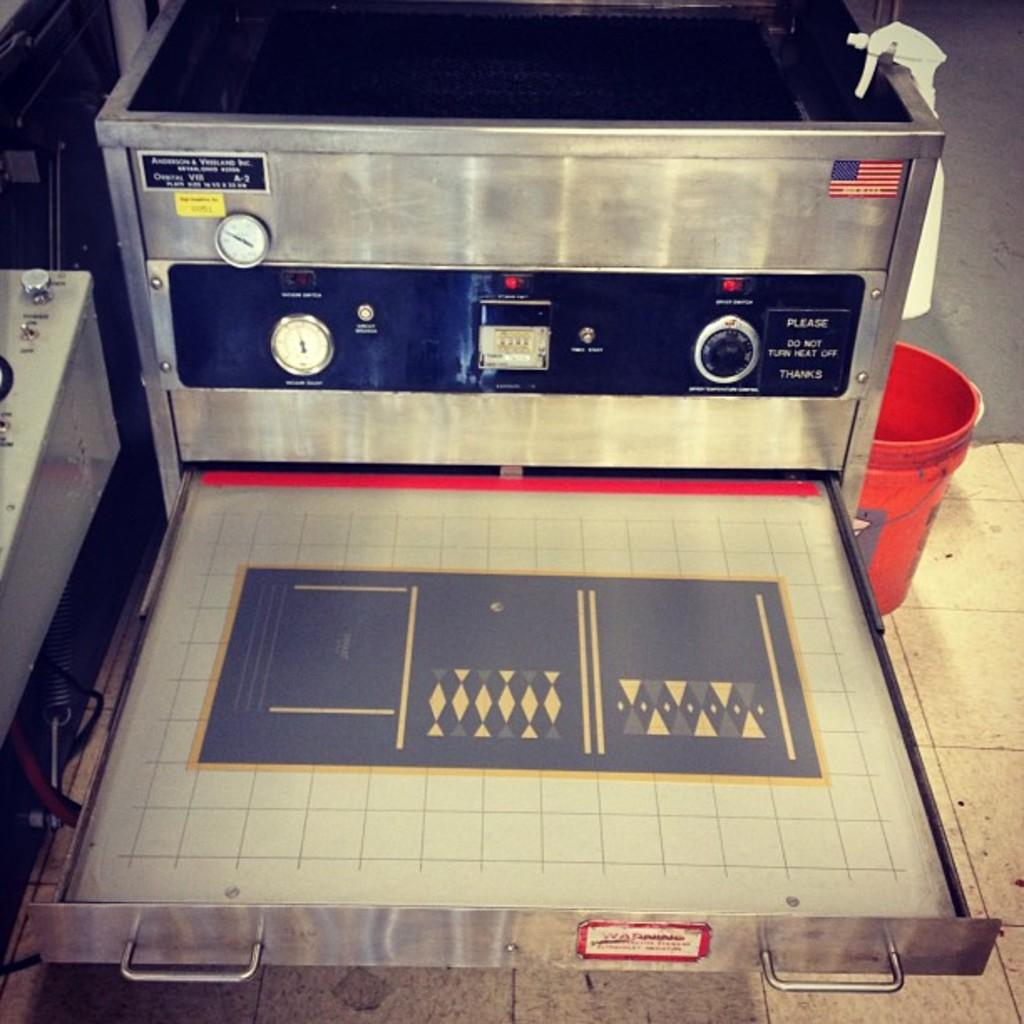<image>
Offer a succinct explanation of the picture presented. A sign attached to a machine asks people to please not turn off the heat. 